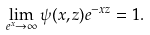<formula> <loc_0><loc_0><loc_500><loc_500>\lim _ { e ^ { x } \to \infty } \psi ( x , z ) e ^ { - x z } = 1 .</formula> 